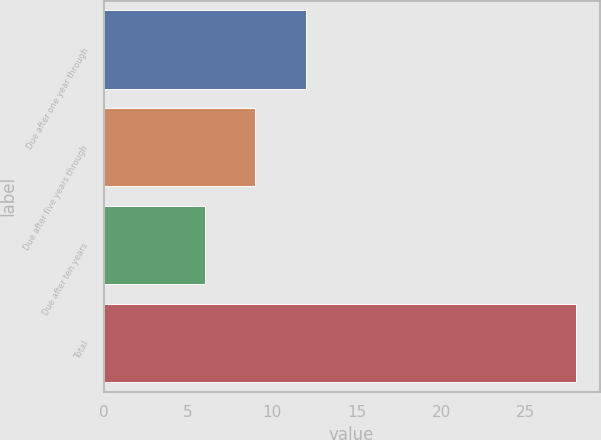<chart> <loc_0><loc_0><loc_500><loc_500><bar_chart><fcel>Due after one year through<fcel>Due after five years through<fcel>Due after ten years<fcel>Total<nl><fcel>12<fcel>9<fcel>6<fcel>28<nl></chart> 